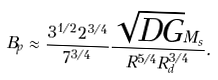Convert formula to latex. <formula><loc_0><loc_0><loc_500><loc_500>B _ { p } \approx \frac { { 3 ^ { 1 / 2 } } 2 ^ { 3 / 4 } } { 7 ^ { 3 / 4 } } \frac { \sqrt { D G } M _ { s } } { R ^ { 5 / 4 } R _ { d } ^ { 3 / 4 } } .</formula> 